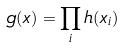Convert formula to latex. <formula><loc_0><loc_0><loc_500><loc_500>g ( x ) = \prod _ { i } h ( x _ { i } )</formula> 